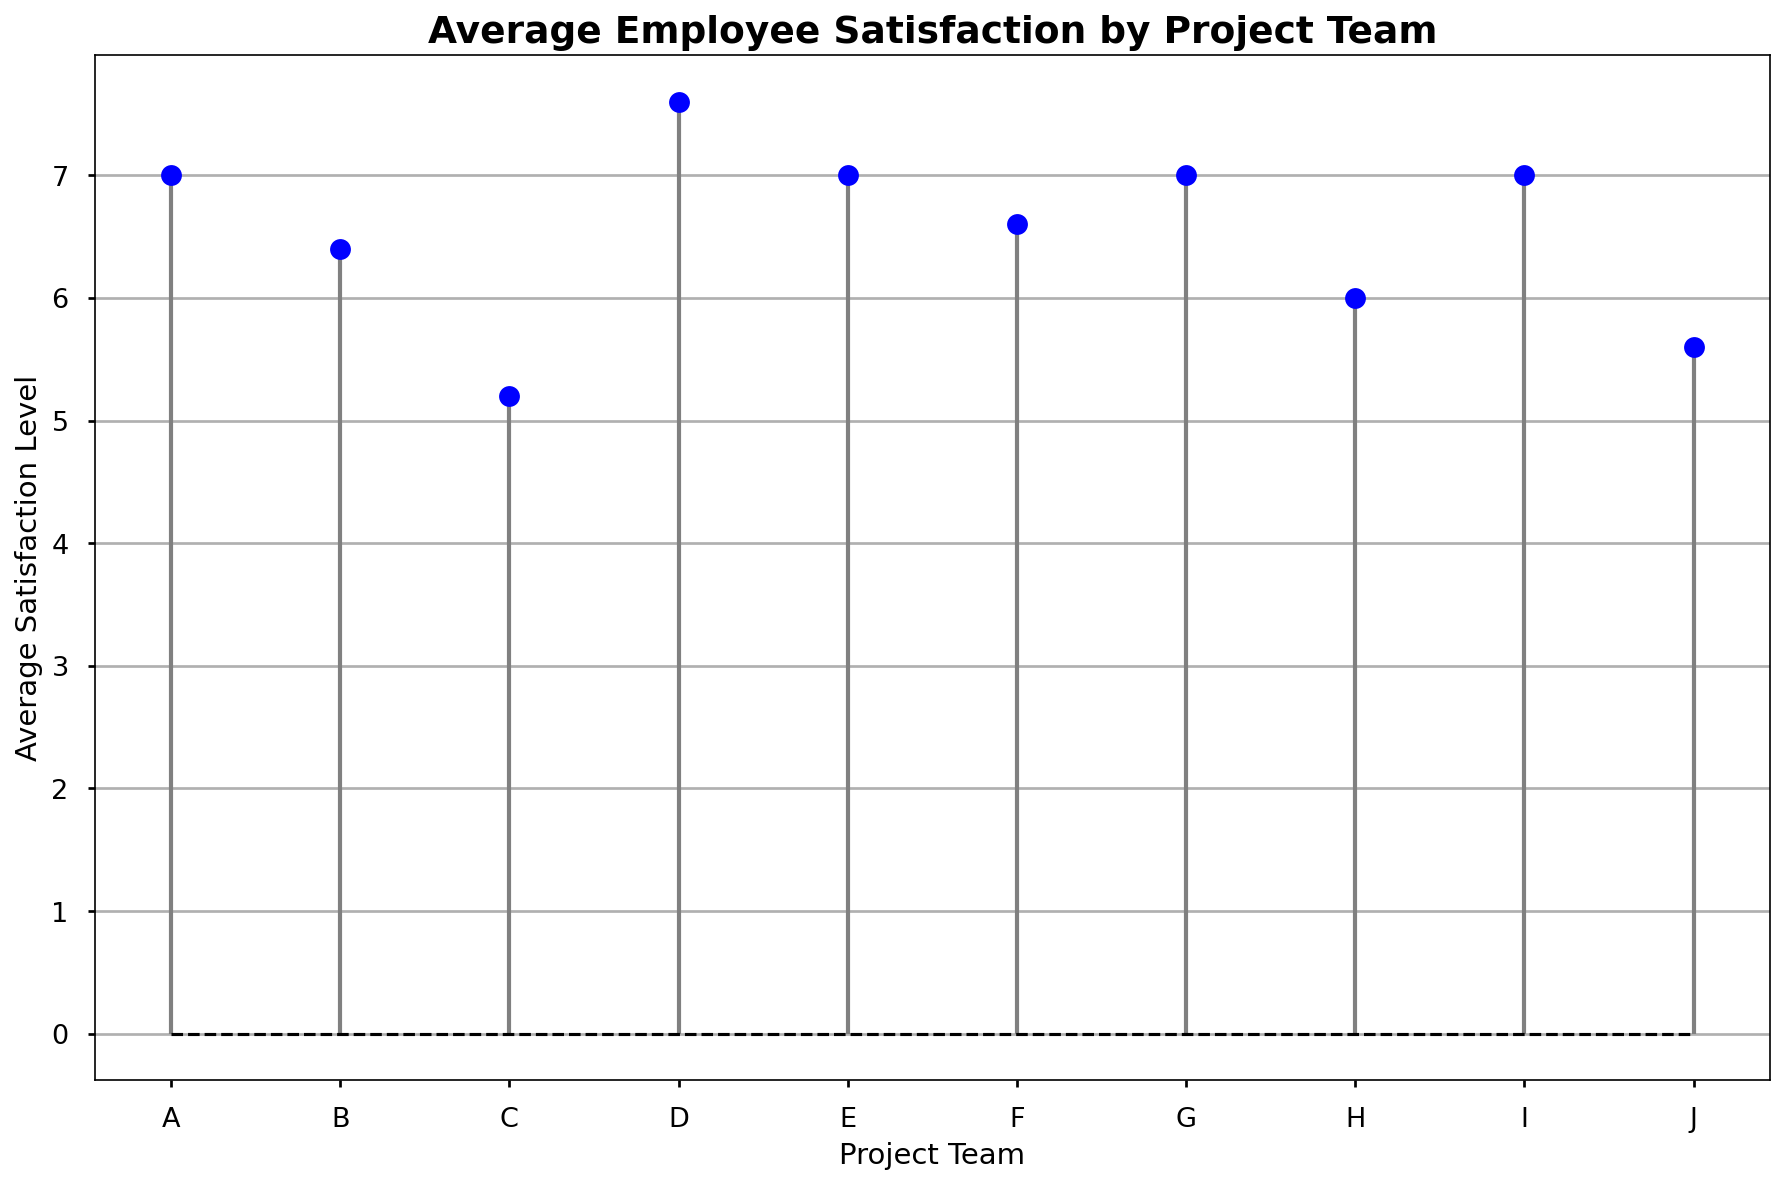Which project team has the highest average satisfaction level? Look at the height of the markers representing the satisfaction levels for each team. The highest marker represents the team with the highest average satisfaction.
Answer: G Which project team has the lowest average satisfaction level? Identify the smallest marker on the plot. The team associated with this marker has the lowest average satisfaction level.
Answer: C What's the difference in average satisfaction levels between team E and team A? Observe the average satisfaction levels of team E and team A, then subtract the value of team A from team E.
Answer: 0 Which teams have an average satisfaction level greater than 7? Check which markers are above the satisfaction level of 7 on the y-axis.
Answer: A, D, G, I What is the average satisfaction level for project team F? Find the marker associated with team F and note its height on the satisfaction level axis.
Answer: 6.6 How many teams have an average satisfaction level below 6? Count the number of markers below the satisfaction level of 6 on the y-axis.
Answer: 2 Compare the average satisfaction levels of team D and team J. Which team has a higher average satisfaction level? Compare the heights of the markers for team D and team J. The higher marker indicates the team with the higher satisfaction level.
Answer: D Which color represents the markers in the plot? Identify the color of the circular markers by visually inspecting the chart.
Answer: Blue If we increased team I's average satisfaction by 1 point, where would its marker be relative to other teams? Calculate the new average by adding 1 to team I's current average satisfaction level, compare this new level with the heights of other markers. Team I would be amongst teams with the highest satisfaction, possibly tied with some.
Answer: Among the highest What's the range in average satisfaction levels across all project teams? Subtract the lowest average satisfaction level from the highest average satisfaction level by looking at the smallest and largest markers.
Answer: 5 